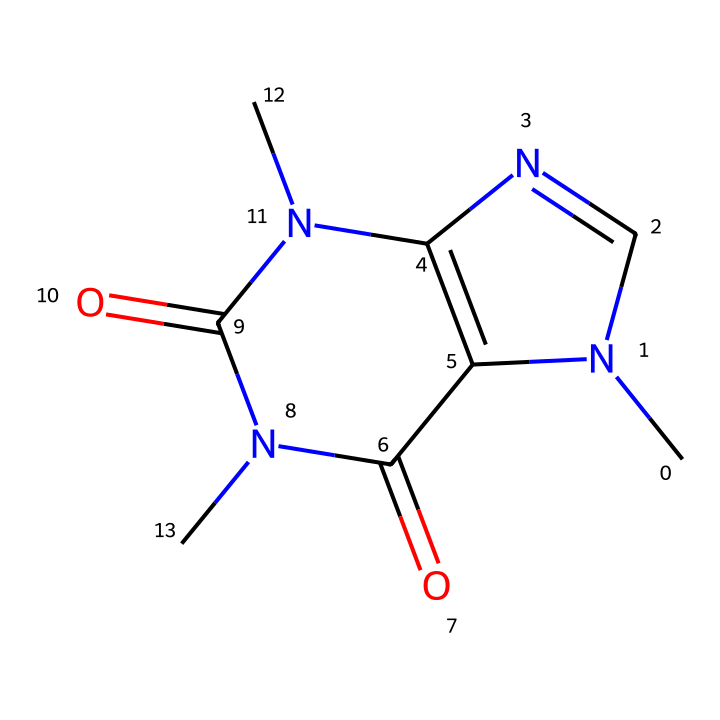What is the molecular formula for caffeine? To find the molecular formula, we identify the types and counts of atoms based on the chemical structure provided by the SMILES notation. The caffeine structure consists of 8 carbon (C) atoms, 10 hydrogen (H) atoms, 4 nitrogen (N) atoms, and 2 oxygen (O) atoms, which gives us a molecular formula of C8H10N4O2.
Answer: C8H10N4O2 How many nitrogen atoms are present in caffeine? By examining the SMILES representation, we can count the nitrogen (N) atoms in the structure. There are four distinct nitrogen atoms indicated in the structure.
Answer: 4 Is caffeine soluble in water? Caffeine is generally classified as a non-electrolyte, which means it does not dissociate into ions in solution. It is, however, soluble in water due to its polarity and hydrogen bonding capabilities.
Answer: yes What type of compound is caffeine? Caffeine is classified as an alkaloid, which are naturally occurring organic compounds that mostly contain basic nitrogen atoms. Analyzing the presence of nitrogen and the overall structure confirms it as an alkaloid.
Answer: alkaloid Which functional groups are present in caffeine? The SMILES representation of caffeine indicates that it contains amine and carbonyl functional groups. The presence of nitrogen atoms connected to hydrogen suggests amines, and the carbonyl groups are indicated by =O notation.
Answer: amine, carbonyl Does caffeine dissociate into ions in solution? As a non-electrolyte, caffeine does not dissociate into ions when dissolved; it remains as whole molecules in solution. This is typical for non-electrolytes and is confirmed by the structure's lack of strongly ionic components.
Answer: no 